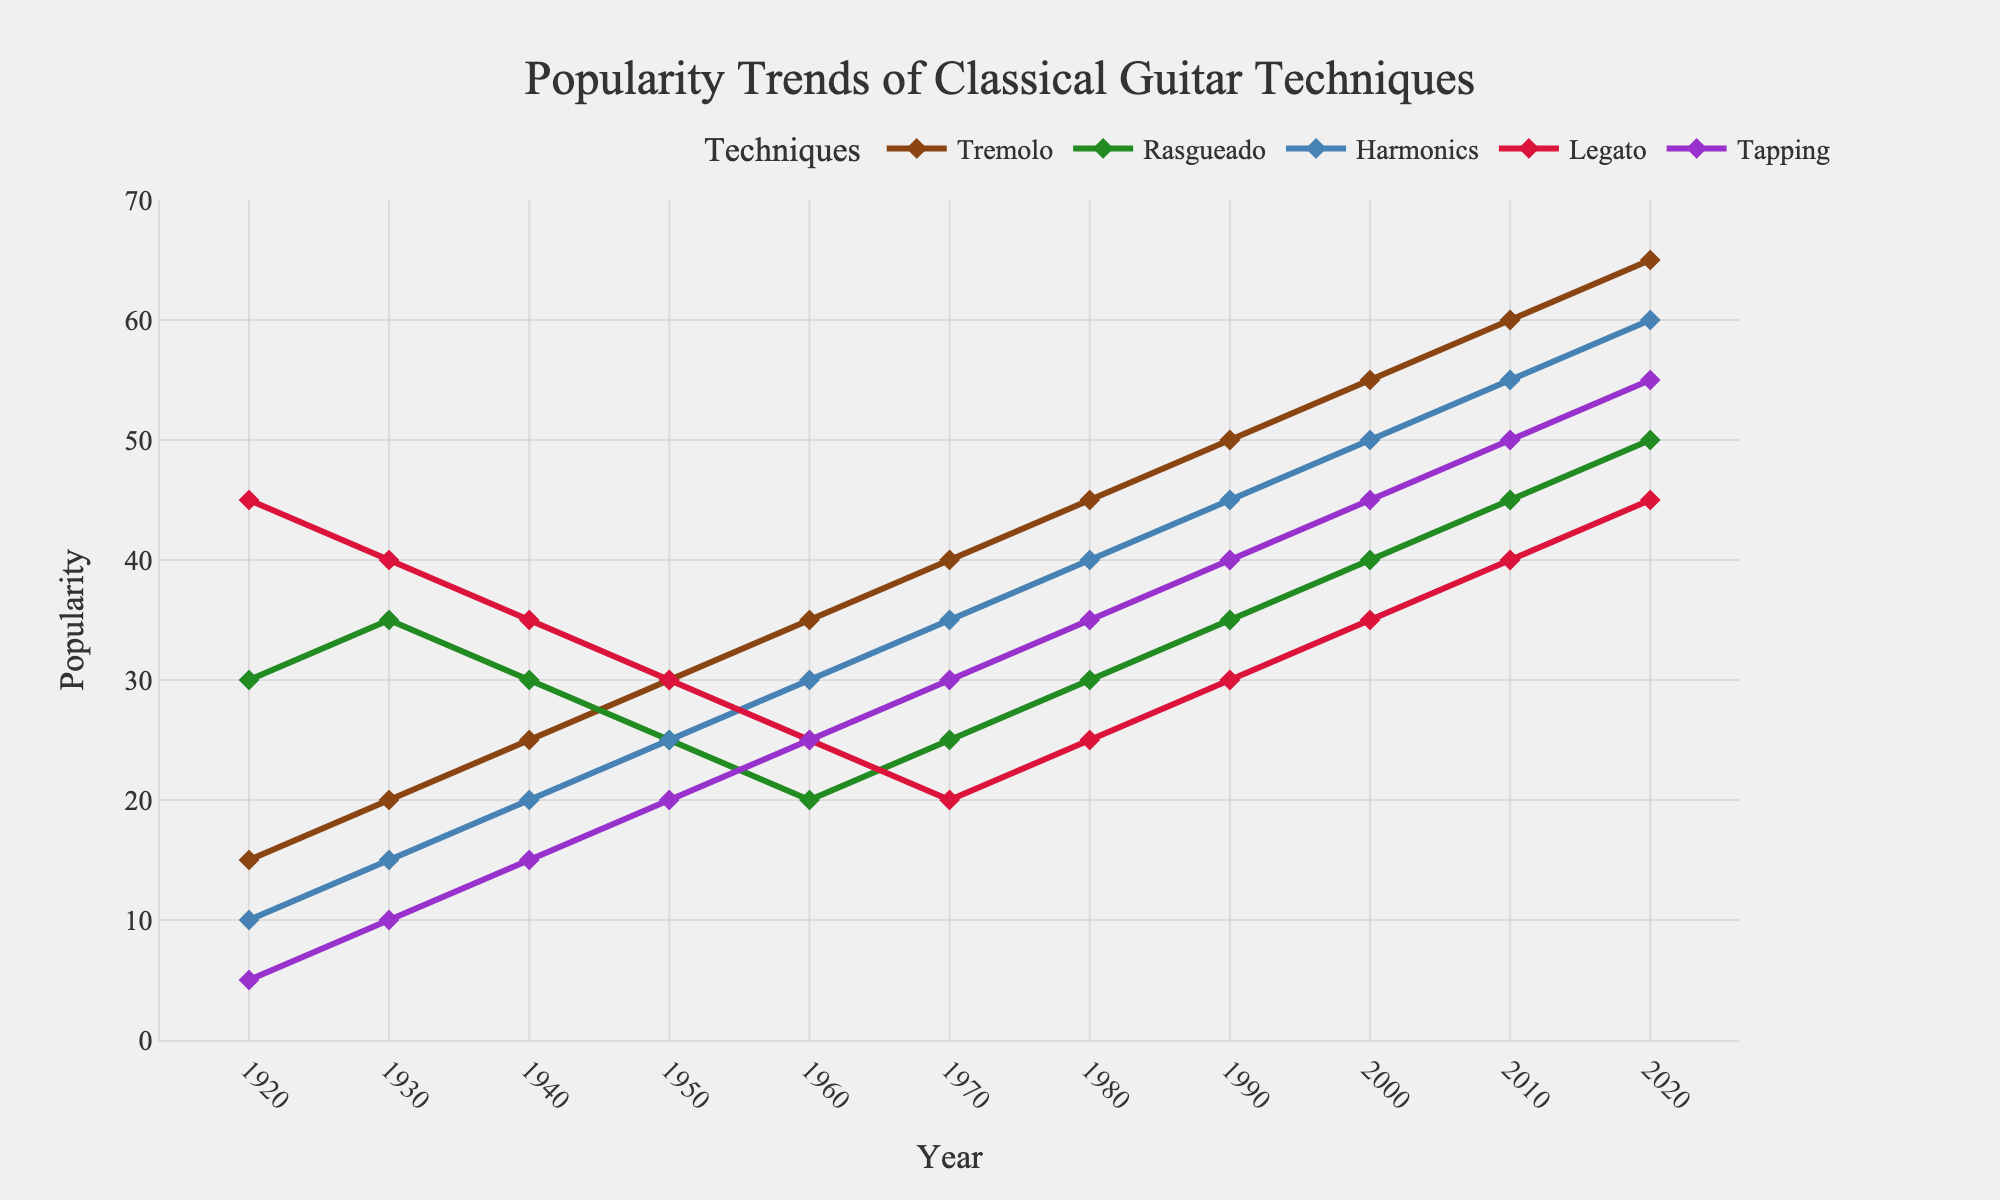What technique had the highest popularity in 1920? The highest popularity in 1920 is indicated by the tallest marker in the chart. The Legato technique had a value of 45, which is the highest among all techniques in 1920.
Answer: Legato How did the popularity of Tremolo change from 2000 to 2020? In 2000, the popularity of Tremolo was 55. By 2020, it increased to 65. Thus, the change in popularity is 65 - 55 = 10.
Answer: Increased by 10 Which technique had the steepest increase in popularity between 1970 and 1980? To find the steepest increase, calculate the difference between 1980 and 1970 for each technique. Tremolo increased from 40 to 45, Rasgueado from 25 to 30, Harmonics from 35 to 40, Legato from 20 to 25, and Tapping from 30 to 35. The increase is the same for all techniques: 5. Therefore, all techniques had the same increase.
Answer: All techniques had the same increase What was the average popularity of the Rasgueado technique over the entire century? First add up all the popularity values for Rasgueado across each decade: 30 + 35 + 30 + 25 + 20 + 25 + 30 + 35 + 40 + 45 + 50 = 365. Then, divide this sum by the number of decades, which is 11. 365 / 11 ≈ 33.18.
Answer: 33.18 Comparing Harmonics and Tapping techniques, which one had a higher popularity in 1950? In 1950, Harmonics had a popularity of 25, while Tapping had 20. Thus, Harmonics had a higher popularity.
Answer: Harmonics What's the total increase in popularity for the Legato technique from 1920 to 2020? The popularity of the Legato technique in 1920 was 45, and it was 45 in 2020. Therefore, the total increase is 45 - 45 = 0.
Answer: 0 What was the difference in popularity between Tremolo and Harmonics in 2010? In 2010, the popularity of Tremolo was 60 and Harmonics was 55. The difference is 60 - 55 = 5.
Answer: 5 Which year saw the peak popularity of the Tapping technique? The peak of the Tapping technique is the highest point in its line on the chart, which occurs in 2020 at a value of 55.
Answer: 2020 Which technique had the most consistent popularity (least fluctuations) over the century? By visually examining the lines, Rasgueado shows the least amount of fluctuation, staying mostly in a range of 20 to 50.
Answer: Rasgueado 